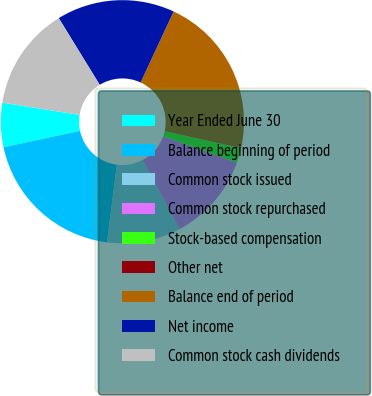Convert chart. <chart><loc_0><loc_0><loc_500><loc_500><pie_chart><fcel>Year Ended June 30<fcel>Balance beginning of period<fcel>Common stock issued<fcel>Common stock repurchased<fcel>Stock-based compensation<fcel>Other net<fcel>Balance end of period<fcel>Net income<fcel>Common stock cash dividends<nl><fcel>5.88%<fcel>19.61%<fcel>9.8%<fcel>11.76%<fcel>1.96%<fcel>0.0%<fcel>21.57%<fcel>15.69%<fcel>13.72%<nl></chart> 